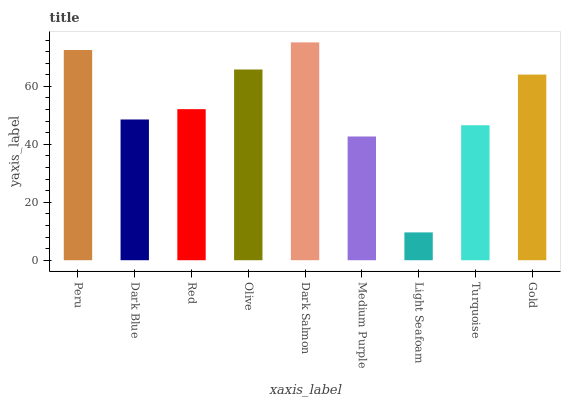Is Light Seafoam the minimum?
Answer yes or no. Yes. Is Dark Salmon the maximum?
Answer yes or no. Yes. Is Dark Blue the minimum?
Answer yes or no. No. Is Dark Blue the maximum?
Answer yes or no. No. Is Peru greater than Dark Blue?
Answer yes or no. Yes. Is Dark Blue less than Peru?
Answer yes or no. Yes. Is Dark Blue greater than Peru?
Answer yes or no. No. Is Peru less than Dark Blue?
Answer yes or no. No. Is Red the high median?
Answer yes or no. Yes. Is Red the low median?
Answer yes or no. Yes. Is Dark Blue the high median?
Answer yes or no. No. Is Peru the low median?
Answer yes or no. No. 